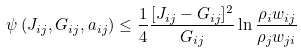<formula> <loc_0><loc_0><loc_500><loc_500>\psi \left ( J _ { i j } , G _ { i j } , a _ { i j } \right ) \leq \frac { 1 } { 4 } \frac { [ J _ { i j } - G _ { i j } ] ^ { 2 } } { G _ { i j } } \ln \frac { \rho _ { i } w _ { i j } } { \rho _ { j } w _ { j i } }</formula> 